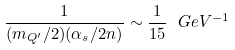Convert formula to latex. <formula><loc_0><loc_0><loc_500><loc_500>\frac { 1 } { ( m _ { Q ^ { \prime } } / 2 ) ( \alpha _ { s } / 2 n ) } \sim \frac { 1 } { 1 5 } \ G e V ^ { - 1 }</formula> 